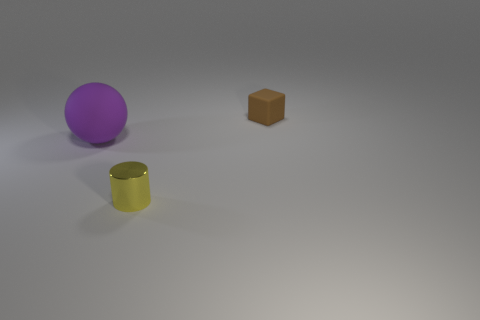Add 1 cyan cylinders. How many objects exist? 4 Subtract all cubes. How many objects are left? 2 Add 1 spheres. How many spheres are left? 2 Add 2 gray cubes. How many gray cubes exist? 2 Subtract 0 red cylinders. How many objects are left? 3 Subtract all big matte balls. Subtract all brown blocks. How many objects are left? 1 